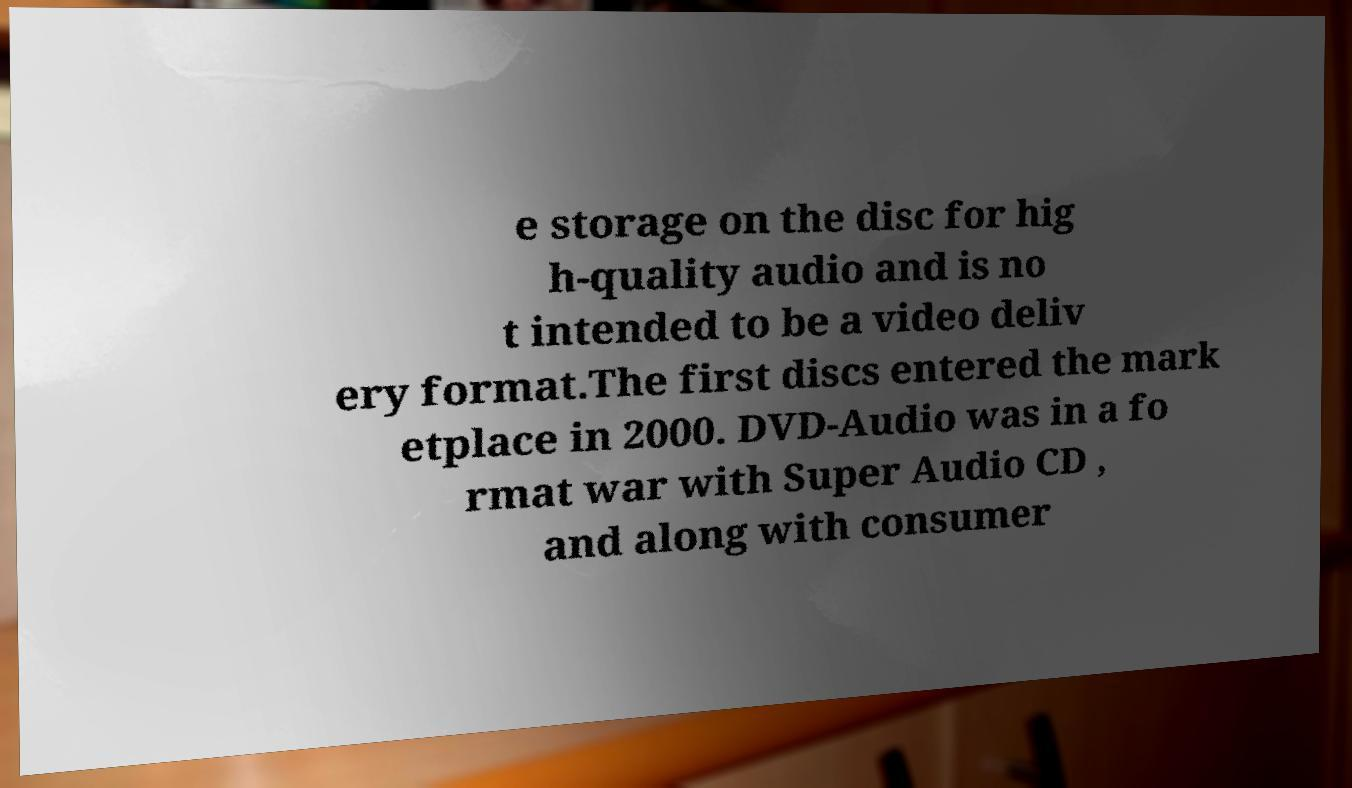Could you assist in decoding the text presented in this image and type it out clearly? e storage on the disc for hig h-quality audio and is no t intended to be a video deliv ery format.The first discs entered the mark etplace in 2000. DVD-Audio was in a fo rmat war with Super Audio CD , and along with consumer 